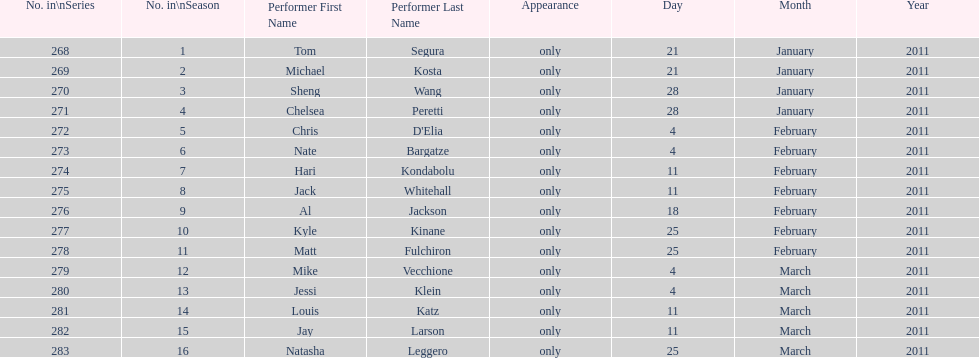What was hari's last name? Kondabolu. 